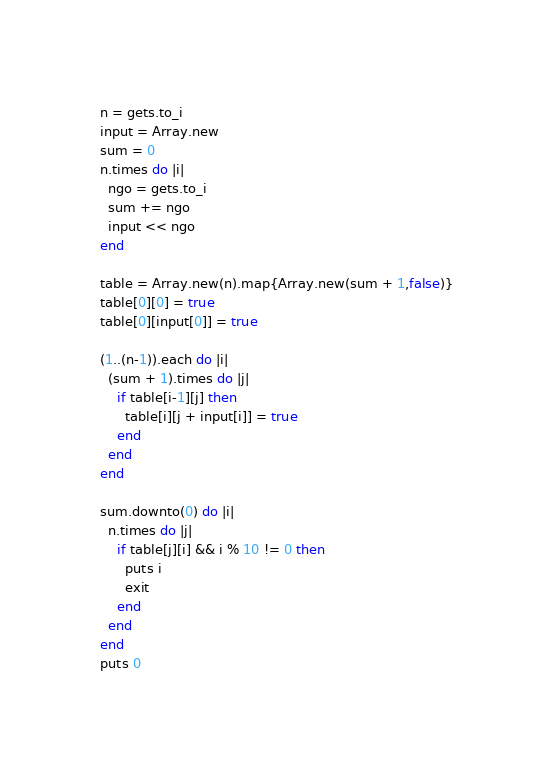Convert code to text. <code><loc_0><loc_0><loc_500><loc_500><_Ruby_>n = gets.to_i
input = Array.new
sum = 0
n.times do |i|
  ngo = gets.to_i
  sum += ngo
  input << ngo
end

table = Array.new(n).map{Array.new(sum + 1,false)}
table[0][0] = true
table[0][input[0]] = true

(1..(n-1)).each do |i|
  (sum + 1).times do |j|
    if table[i-1][j] then
      table[i][j + input[i]] = true
    end
  end
end

sum.downto(0) do |i|
  n.times do |j|
    if table[j][i] && i % 10 != 0 then
      puts i
      exit
    end
  end
end
puts 0</code> 